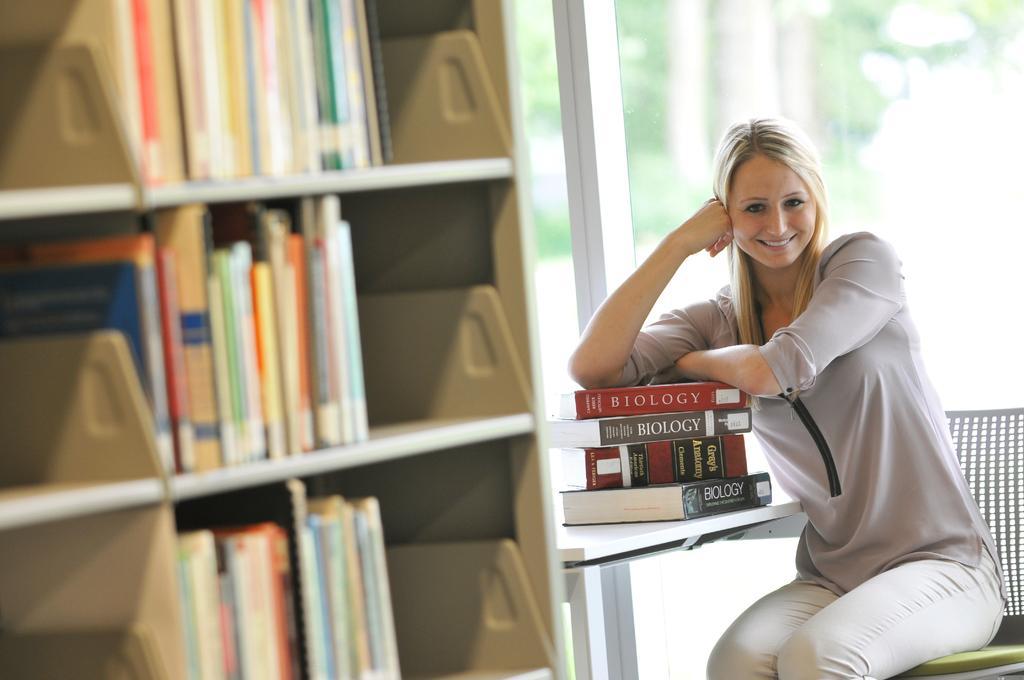How would you summarize this image in a sentence or two? In this picture a lady is sitting on the table with biology books on top of it , to the left side of the picture there is a wooden shelf in which books are fitted. In the background there is a glass door. 